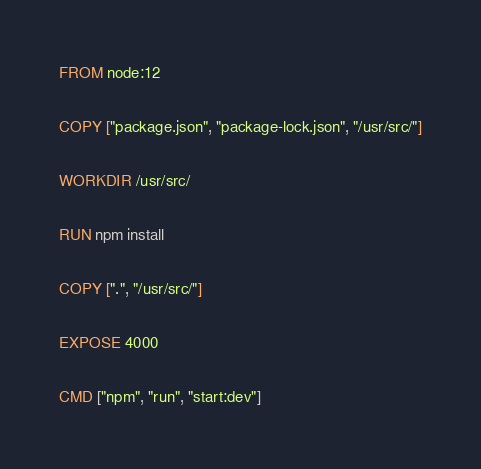Convert code to text. <code><loc_0><loc_0><loc_500><loc_500><_Dockerfile_>FROM node:12

COPY ["package.json", "package-lock.json", "/usr/src/"]

WORKDIR /usr/src/

RUN npm install

COPY [".", "/usr/src/"]

EXPOSE 4000

CMD ["npm", "run", "start:dev"]</code> 